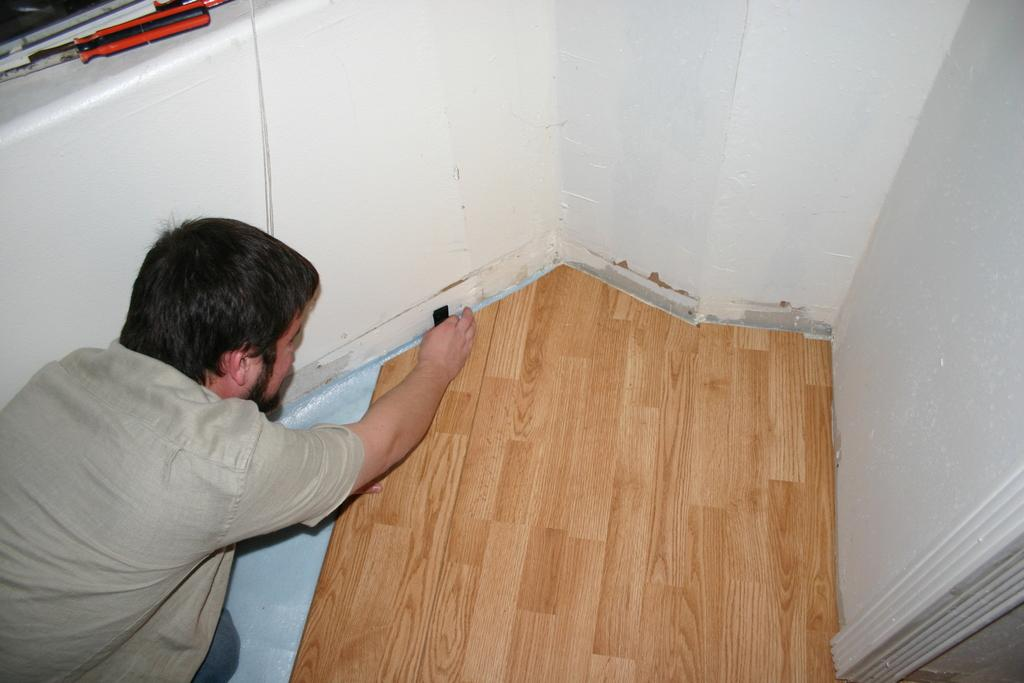Who or what is present on the left side of the image? There is a person on the left side of the image. What type of surface can be seen in the image? There is a wooden surface in the image. What encloses the scene in the image? The scene is surrounded by walls. Can you tell me how the horse is involved in the person's journey in the image? There is no horse present in the image, and therefore no such involvement can be observed. 